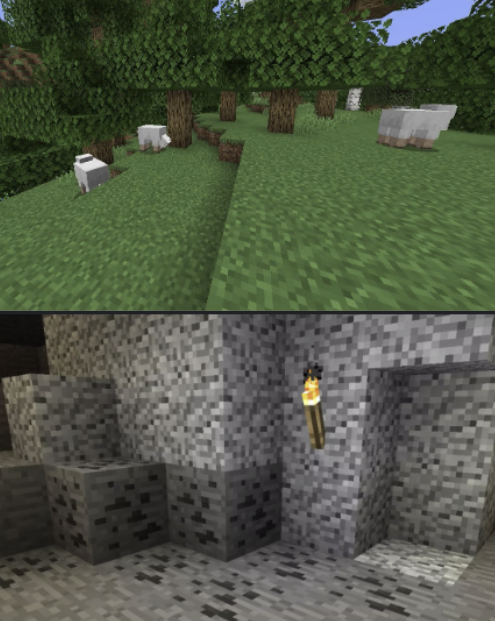You are a Minecraft Player. Your current high-level task is: 'mine redstone'. Your current low-level task is: 'find a creeper'. Your inventory has the following in it: nothing.

First, critique your low-level task in light of your high-level task, keeping your inventory in mind. If it is not the appropriate low-level task, please suggest a different one. Start by listing some intermediate steps. For instance, if your high-level task is "make a cobblestone pickaxe" and your inventory contains "sticks", you might say "to make a cobblestone pickaxe, I need a crafting bench, sticks, and cobblestone. I lack a crafting bench and cobblestone. To make a crafting bench, I need wood, which I lack. Therefore, my next low-level task should be 'get wood'"

There are two scenes provided, top and bottom. Please describe them both, as though you were trying to convey the image to a blind person. Be specific, but don't give unnecessary emotional descriptions. For instance, if the image were of a forest biome, "a lush verdant forest, beautiful and pleasing to the eye" would be a bad description; a better description would be "A forest biome. You see many birch trees. There is a sheep in the distance. There is one sapling on the ground. It is daytime." In your final description, take note of any details that may be relevant to your current low-level task.

Then, rate the desirability of both scenes, given your current tasks and inventory. Explain your reasoning, and indicate which scene you prefer. Your response MUST include one of the following phrases: "I prefer the top"; "I prefer the bottom"; or, in the case where both are equally preferable (or equally bad) "I prefer neither". Critique of low-level task:
To mine redstone, I need to find redstone ore deep underground. Finding a creeper is not directly related to this goal. Intermediate steps to mine redstone would be:
1. Craft a pickaxe (at least iron tier)
2. Gather torches for light
3. Dig deep underground (around Y-level 15)
4. Locate and mine redstone ore

Given that I have nothing in my inventory, my next low-level task should be "gather wood" to start the tool-making process.

Scene descriptions:
Top scene: A forest biome. There are several oak trees visible. The ground is covered in grass blocks. Three white sheep are grazing in the area. It is daytime.

Bottom scene: An underground cave environment. The walls, floor, and ceiling are made of stone blocks. There is a torch mounted on the wall, providing light. The stone blocks have a mottled appearance, indicating different types of stone (possibly including ore).

Desirability rating:
I prefer the top scene. The forest biome is more desirable for my current situation because:

1. It provides easy access to wood, which I need to start crafting tools.
2. The sheep could provide wool if I need to make a bed later.
3. The surface location allows me to establish a base and prepare before venturing underground.

While the bottom scene is closer to where I'll eventually need to be for mining redstone, I'm not equipped to handle cave exploration or mining yet. The top scene offers the resources I need to begin my journey towards the ultimate goal of mining redstone. 